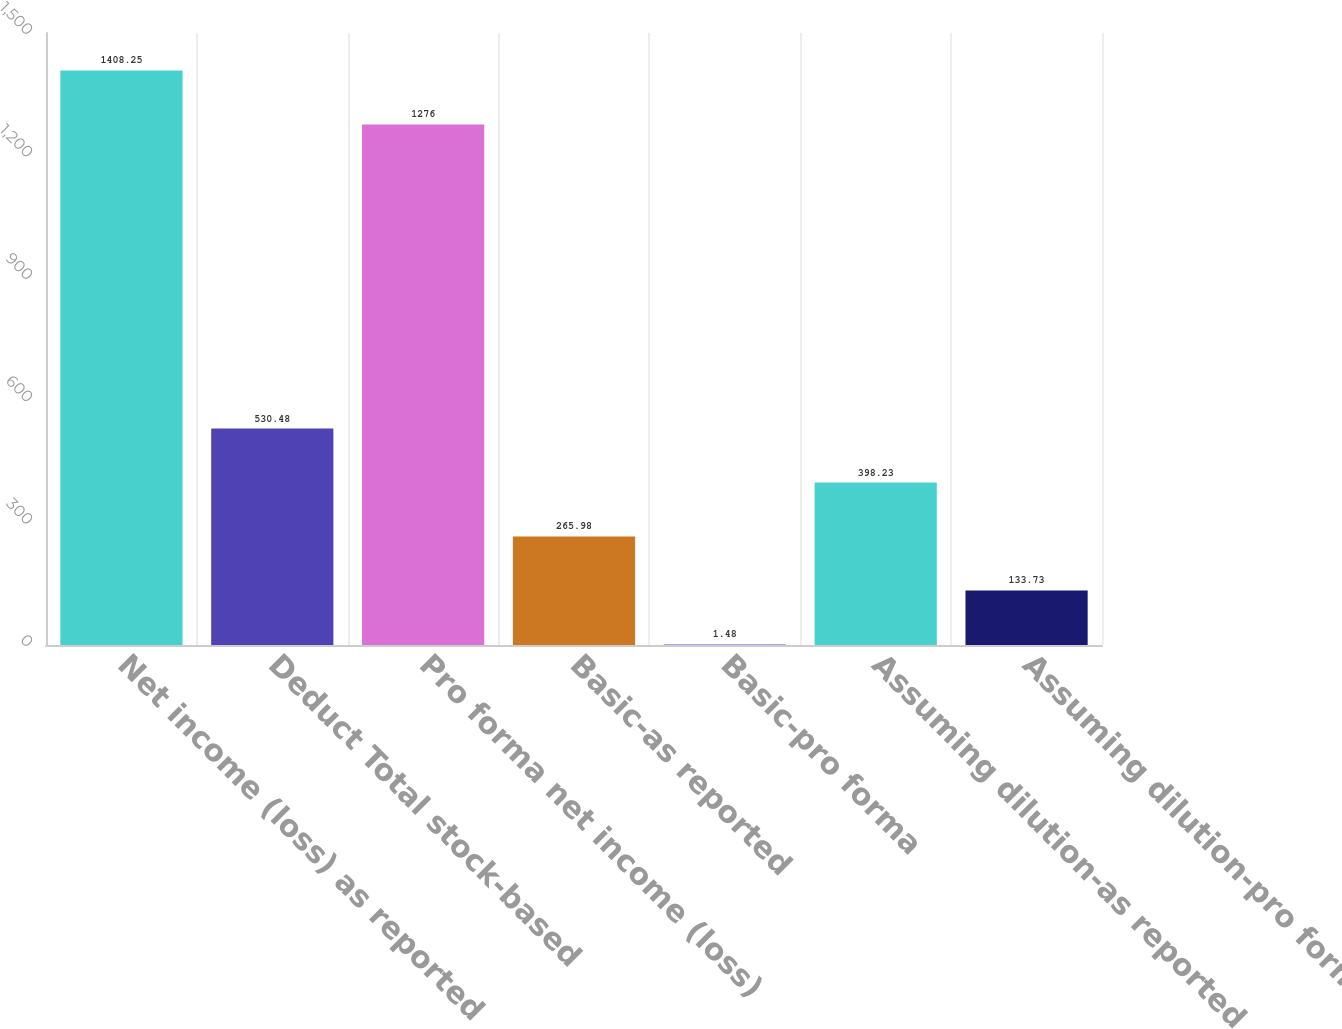Convert chart to OTSL. <chart><loc_0><loc_0><loc_500><loc_500><bar_chart><fcel>Net income (loss) as reported<fcel>Deduct Total stock-based<fcel>Pro forma net income (loss)<fcel>Basic-as reported<fcel>Basic-pro forma<fcel>Assuming dilution-as reported<fcel>Assuming dilution-pro forma<nl><fcel>1408.25<fcel>530.48<fcel>1276<fcel>265.98<fcel>1.48<fcel>398.23<fcel>133.73<nl></chart> 